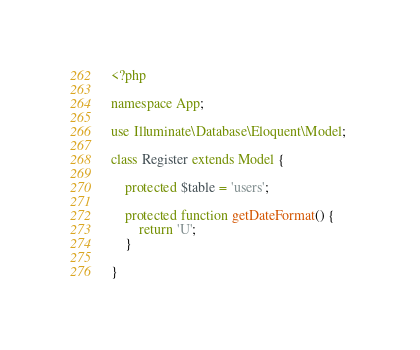Convert code to text. <code><loc_0><loc_0><loc_500><loc_500><_PHP_><?php

namespace App;
 
use Illuminate\Database\Eloquent\Model; 

class Register extends Model {
    
    protected $table = 'users';

    protected function getDateFormat() {
        return 'U';
    }

}
</code> 